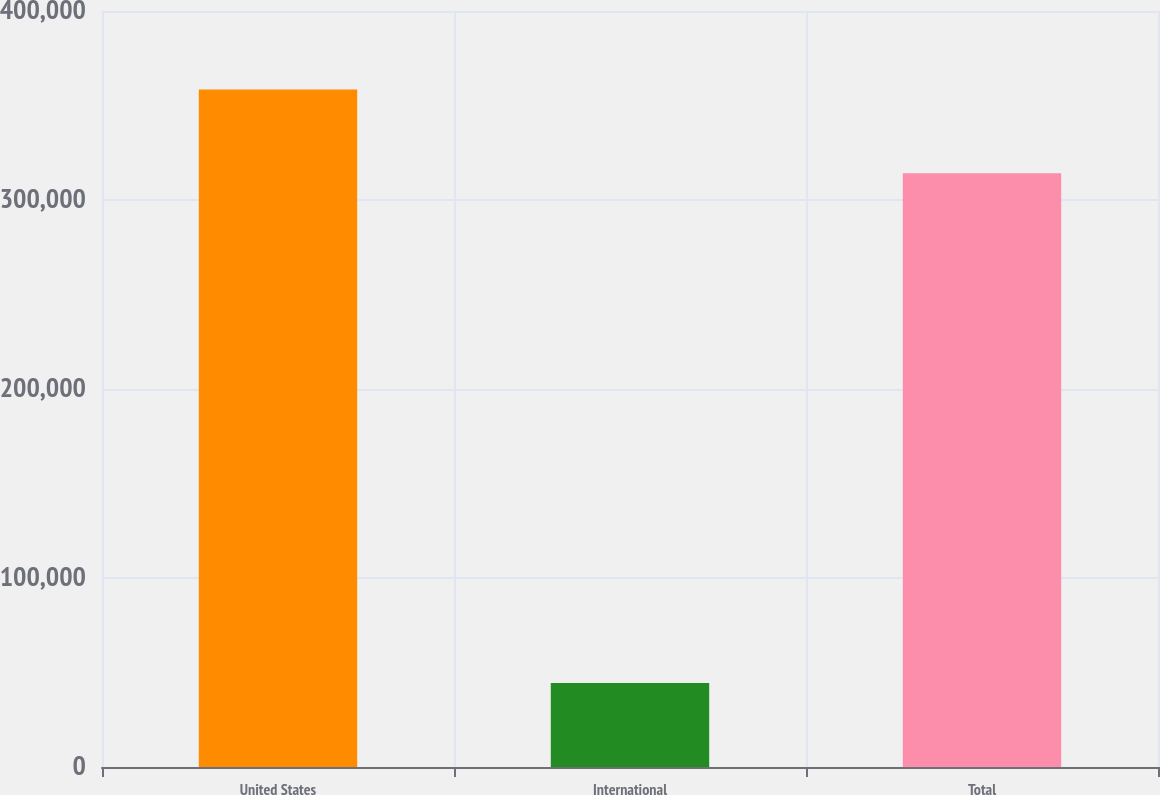Convert chart to OTSL. <chart><loc_0><loc_0><loc_500><loc_500><bar_chart><fcel>United States<fcel>International<fcel>Total<nl><fcel>358520<fcel>44383<fcel>314137<nl></chart> 